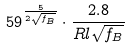Convert formula to latex. <formula><loc_0><loc_0><loc_500><loc_500>5 9 ^ { \frac { 5 } { 2 \sqrt { f _ { B } } } } \cdot \frac { 2 . 8 } { R l \sqrt { f _ { B } } }</formula> 